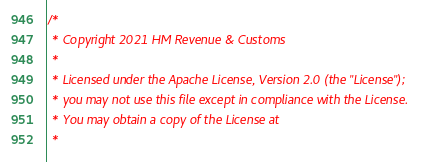Convert code to text. <code><loc_0><loc_0><loc_500><loc_500><_Scala_>/*
 * Copyright 2021 HM Revenue & Customs
 *
 * Licensed under the Apache License, Version 2.0 (the "License");
 * you may not use this file except in compliance with the License.
 * You may obtain a copy of the License at
 *</code> 